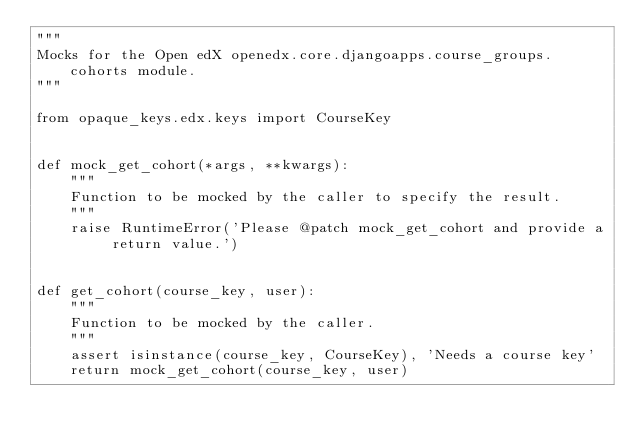Convert code to text. <code><loc_0><loc_0><loc_500><loc_500><_Python_>"""
Mocks for the Open edX openedx.core.djangoapps.course_groups.cohorts module.
"""

from opaque_keys.edx.keys import CourseKey


def mock_get_cohort(*args, **kwargs):
    """
    Function to be mocked by the caller to specify the result.
    """
    raise RuntimeError('Please @patch mock_get_cohort and provide a return value.')


def get_cohort(course_key, user):
    """
    Function to be mocked by the caller.
    """
    assert isinstance(course_key, CourseKey), 'Needs a course key'
    return mock_get_cohort(course_key, user)
</code> 